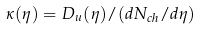Convert formula to latex. <formula><loc_0><loc_0><loc_500><loc_500>\kappa ( \eta ) = D _ { u } ( \eta ) / ( d N _ { c h } / d { \eta } )</formula> 